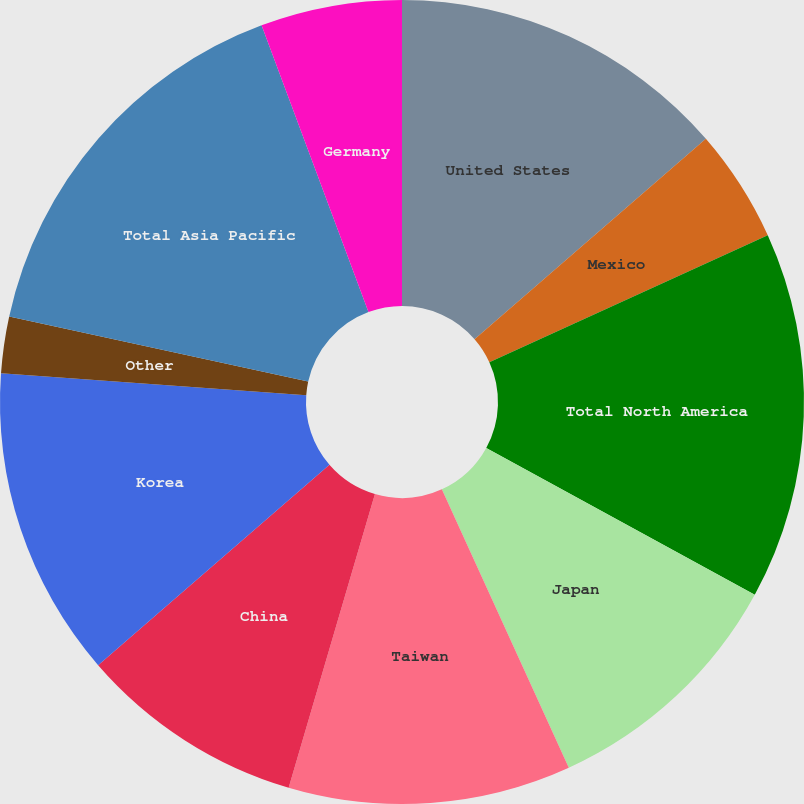Convert chart. <chart><loc_0><loc_0><loc_500><loc_500><pie_chart><fcel>United States<fcel>Mexico<fcel>Total North America<fcel>Japan<fcel>Taiwan<fcel>China<fcel>Korea<fcel>Other<fcel>Total Asia Pacific<fcel>Germany<nl><fcel>13.64%<fcel>4.55%<fcel>14.77%<fcel>10.23%<fcel>11.36%<fcel>9.09%<fcel>12.5%<fcel>2.27%<fcel>15.91%<fcel>5.68%<nl></chart> 